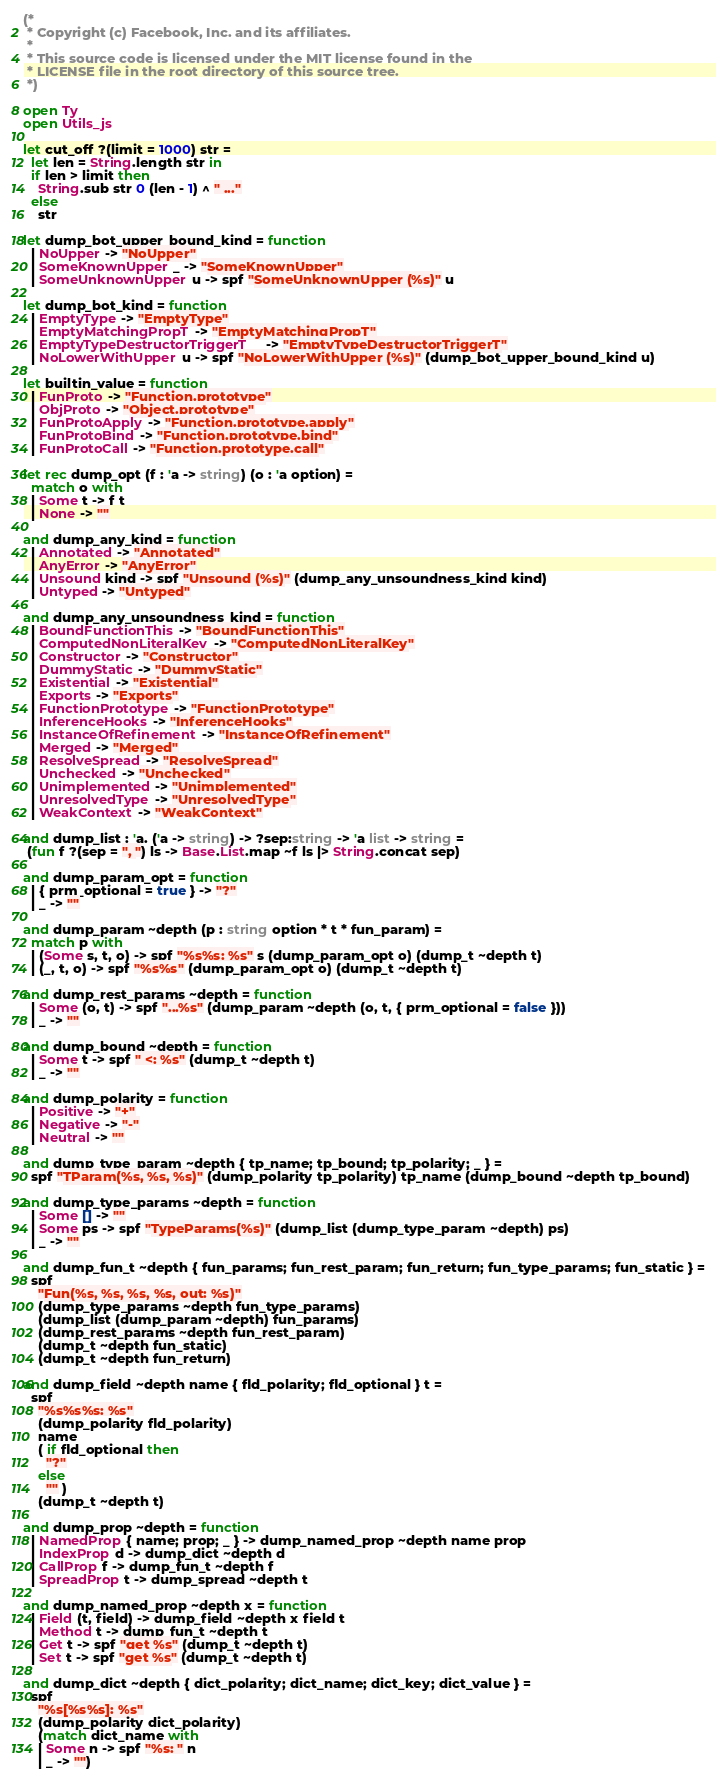Convert code to text. <code><loc_0><loc_0><loc_500><loc_500><_OCaml_>(*
 * Copyright (c) Facebook, Inc. and its affiliates.
 *
 * This source code is licensed under the MIT license found in the
 * LICENSE file in the root directory of this source tree.
 *)

open Ty
open Utils_js

let cut_off ?(limit = 1000) str =
  let len = String.length str in
  if len > limit then
    String.sub str 0 (len - 1) ^ " ..."
  else
    str

let dump_bot_upper_bound_kind = function
  | NoUpper -> "NoUpper"
  | SomeKnownUpper _ -> "SomeKnownUpper"
  | SomeUnknownUpper u -> spf "SomeUnknownUpper (%s)" u

let dump_bot_kind = function
  | EmptyType -> "EmptyType"
  | EmptyMatchingPropT -> "EmptyMatchingPropT"
  | EmptyTypeDestructorTriggerT _ -> "EmptyTypeDestructorTriggerT"
  | NoLowerWithUpper u -> spf "NoLowerWithUpper (%s)" (dump_bot_upper_bound_kind u)

let builtin_value = function
  | FunProto -> "Function.prototype"
  | ObjProto -> "Object.prototype"
  | FunProtoApply -> "Function.prototype.apply"
  | FunProtoBind -> "Function.prototype.bind"
  | FunProtoCall -> "Function.prototype.call"

let rec dump_opt (f : 'a -> string) (o : 'a option) =
  match o with
  | Some t -> f t
  | None -> ""

and dump_any_kind = function
  | Annotated -> "Annotated"
  | AnyError -> "AnyError"
  | Unsound kind -> spf "Unsound (%s)" (dump_any_unsoundness_kind kind)
  | Untyped -> "Untyped"

and dump_any_unsoundness_kind = function
  | BoundFunctionThis -> "BoundFunctionThis"
  | ComputedNonLiteralKey -> "ComputedNonLiteralKey"
  | Constructor -> "Constructor"
  | DummyStatic -> "DummyStatic"
  | Existential -> "Existential"
  | Exports -> "Exports"
  | FunctionPrototype -> "FunctionPrototype"
  | InferenceHooks -> "InferenceHooks"
  | InstanceOfRefinement -> "InstanceOfRefinement"
  | Merged -> "Merged"
  | ResolveSpread -> "ResolveSpread"
  | Unchecked -> "Unchecked"
  | Unimplemented -> "Unimplemented"
  | UnresolvedType -> "UnresolvedType"
  | WeakContext -> "WeakContext"

and dump_list : 'a. ('a -> string) -> ?sep:string -> 'a list -> string =
 (fun f ?(sep = ", ") ls -> Base.List.map ~f ls |> String.concat sep)

and dump_param_opt = function
  | { prm_optional = true } -> "?"
  | _ -> ""

and dump_param ~depth (p : string option * t * fun_param) =
  match p with
  | (Some s, t, o) -> spf "%s%s: %s" s (dump_param_opt o) (dump_t ~depth t)
  | (_, t, o) -> spf "%s%s" (dump_param_opt o) (dump_t ~depth t)

and dump_rest_params ~depth = function
  | Some (o, t) -> spf "...%s" (dump_param ~depth (o, t, { prm_optional = false }))
  | _ -> ""

and dump_bound ~depth = function
  | Some t -> spf " <: %s" (dump_t ~depth t)
  | _ -> ""

and dump_polarity = function
  | Positive -> "+"
  | Negative -> "-"
  | Neutral -> ""

and dump_type_param ~depth { tp_name; tp_bound; tp_polarity; _ } =
  spf "TParam(%s, %s, %s)" (dump_polarity tp_polarity) tp_name (dump_bound ~depth tp_bound)

and dump_type_params ~depth = function
  | Some [] -> ""
  | Some ps -> spf "TypeParams(%s)" (dump_list (dump_type_param ~depth) ps)
  | _ -> ""

and dump_fun_t ~depth { fun_params; fun_rest_param; fun_return; fun_type_params; fun_static } =
  spf
    "Fun(%s, %s, %s, %s, out: %s)"
    (dump_type_params ~depth fun_type_params)
    (dump_list (dump_param ~depth) fun_params)
    (dump_rest_params ~depth fun_rest_param)
    (dump_t ~depth fun_static)
    (dump_t ~depth fun_return)

and dump_field ~depth name { fld_polarity; fld_optional } t =
  spf
    "%s%s%s: %s"
    (dump_polarity fld_polarity)
    name
    ( if fld_optional then
      "?"
    else
      "" )
    (dump_t ~depth t)

and dump_prop ~depth = function
  | NamedProp { name; prop; _ } -> dump_named_prop ~depth name prop
  | IndexProp d -> dump_dict ~depth d
  | CallProp f -> dump_fun_t ~depth f
  | SpreadProp t -> dump_spread ~depth t

and dump_named_prop ~depth x = function
  | Field (t, field) -> dump_field ~depth x field t
  | Method t -> dump_fun_t ~depth t
  | Get t -> spf "get %s" (dump_t ~depth t)
  | Set t -> spf "get %s" (dump_t ~depth t)

and dump_dict ~depth { dict_polarity; dict_name; dict_key; dict_value } =
  spf
    "%s[%s%s]: %s"
    (dump_polarity dict_polarity)
    (match dict_name with
    | Some n -> spf "%s: " n
    | _ -> "")</code> 